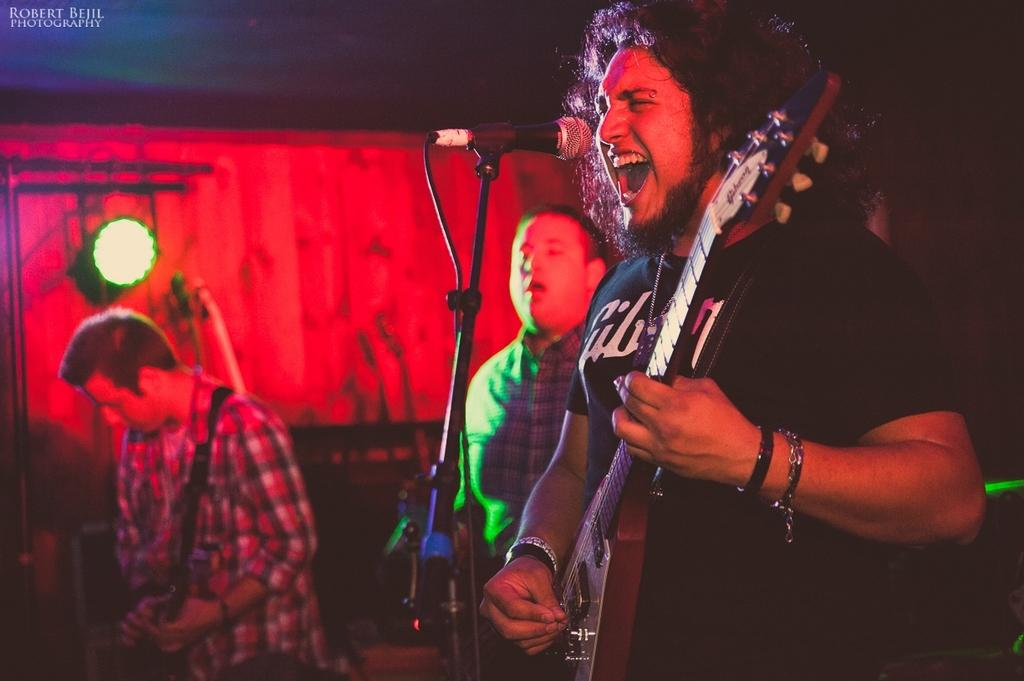What are the two persons in the image doing? A: The two persons in the image are playing guitar. Can you describe the actions of the person holding a microphone? One person is holding a microphone. What is the third person doing in the image? Another person is playing a musical instrument. How many ants can be seen crawling on the guitar in the image? There are no ants visible in the image; it features two persons playing guitar and another person playing a musical instrument. What type of pleasure can be experienced by the musicians in the image? The image does not convey any information about the musicians' emotions or experiences, so it is not possible to determine the type of pleasure they might be experiencing. 